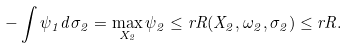Convert formula to latex. <formula><loc_0><loc_0><loc_500><loc_500>- \int \psi _ { 1 } d \sigma _ { 2 } = \max _ { X _ { 2 } } \psi _ { 2 } \leq r R ( X _ { 2 } , \omega _ { 2 } , \sigma _ { 2 } ) \leq r R .</formula> 